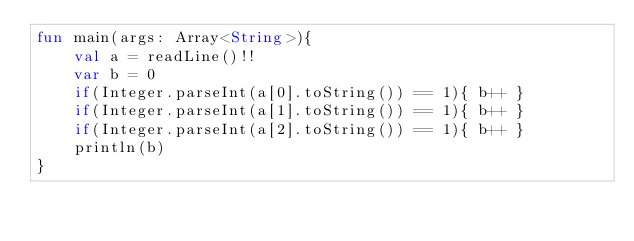<code> <loc_0><loc_0><loc_500><loc_500><_Kotlin_>fun main(args: Array<String>){
    val a = readLine()!!
    var b = 0
    if(Integer.parseInt(a[0].toString()) == 1){ b++ }
    if(Integer.parseInt(a[1].toString()) == 1){ b++ }
    if(Integer.parseInt(a[2].toString()) == 1){ b++ }
    println(b)
}
</code> 